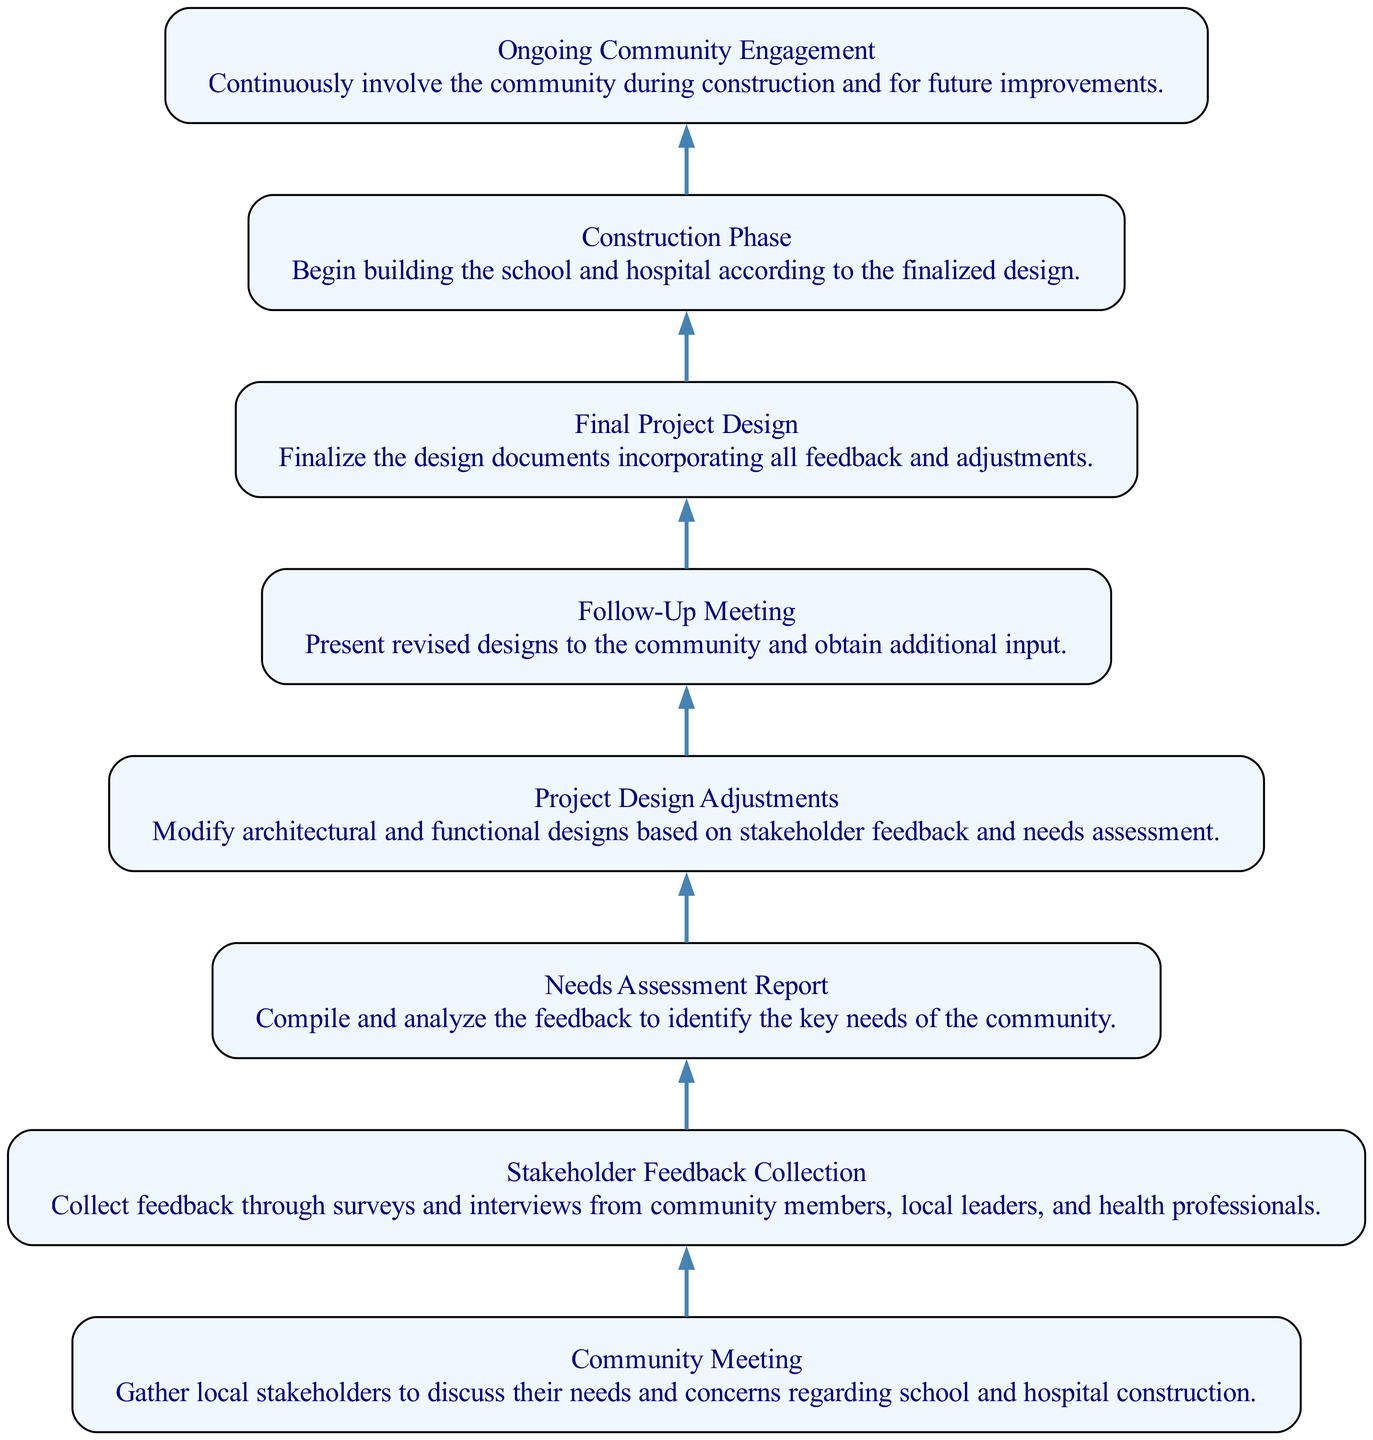What is the first step in the community engagement strategy? The first step is the "Community Meeting," where local stakeholders are gathered to discuss their needs and concerns regarding the construction.
Answer: Community Meeting How many nodes are present in the diagram? The diagram features eight distinct nodes representing various stages of the community engagement strategy.
Answer: 8 What is the relationship between stakeholder feedback collection and needs assessment? Stakeholder feedback collection leads directly to needs assessment, indicating that the feedback gathered is analyzed to compile a report on community needs.
Answer: Stakeholder feedback collection leads to needs assessment What type of meeting occurs after design adjustments? A Follow-Up Meeting occurs after design adjustments, allowing for community input on the revised designs.
Answer: Follow-Up Meeting What is the last phase of the community engagement strategy? The last phase is "Ongoing Community Engagement," which emphasizes continuous involvement with the community even after construction.
Answer: Ongoing Community Engagement Which step precedes the final project design? The step that precedes the final project design is the follow-up meeting where revised designs are presented for further input.
Answer: Follow-Up Meeting How do the project design adjustments relate to stakeholder feedback? Project design adjustments are made specifically based on the feedback collected from stakeholders, ensuring the final design aligns with community needs.
Answer: Project design adjustments are based on stakeholder feedback Which node represents the transition from planning to execution? The transition from planning to execution is represented by the "Construction Phase," where building begins based on the finalized design.
Answer: Construction Phase What step occurs after the needs assessment report? The step that occurs after the needs assessment report is the project design adjustments, indicating that design modifications follow the identification of community needs.
Answer: Project Design Adjustments 